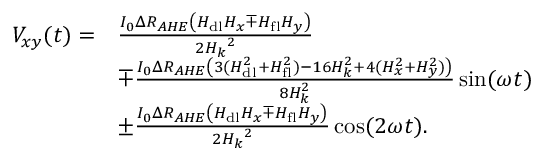<formula> <loc_0><loc_0><loc_500><loc_500>\begin{array} { r l } { V _ { x y } ( t ) = } & { \frac { I _ { 0 } \Delta R _ { A H E } \left ( H _ { d l } H _ { x } \mp H _ { f l } H _ { y } \right ) } { 2 { H _ { k } } ^ { 2 } } } \\ & { \mp \frac { I _ { 0 } \Delta R _ { A H E } \left ( 3 ( H _ { d l } ^ { 2 } + H _ { f l } ^ { 2 } ) - 1 6 H _ { k } ^ { 2 } + 4 ( H _ { x } ^ { 2 } + H _ { y } ^ { 2 } ) \right ) } { 8 H _ { k } ^ { 2 } } \sin ( \omega t ) } \\ & { \pm \frac { I _ { 0 } \Delta R _ { A H E } \left ( H _ { d l } H _ { x } \mp H _ { f l } H _ { y } \right ) } { 2 { H _ { k } } ^ { 2 } } \cos ( 2 \omega t ) . } \end{array}</formula> 